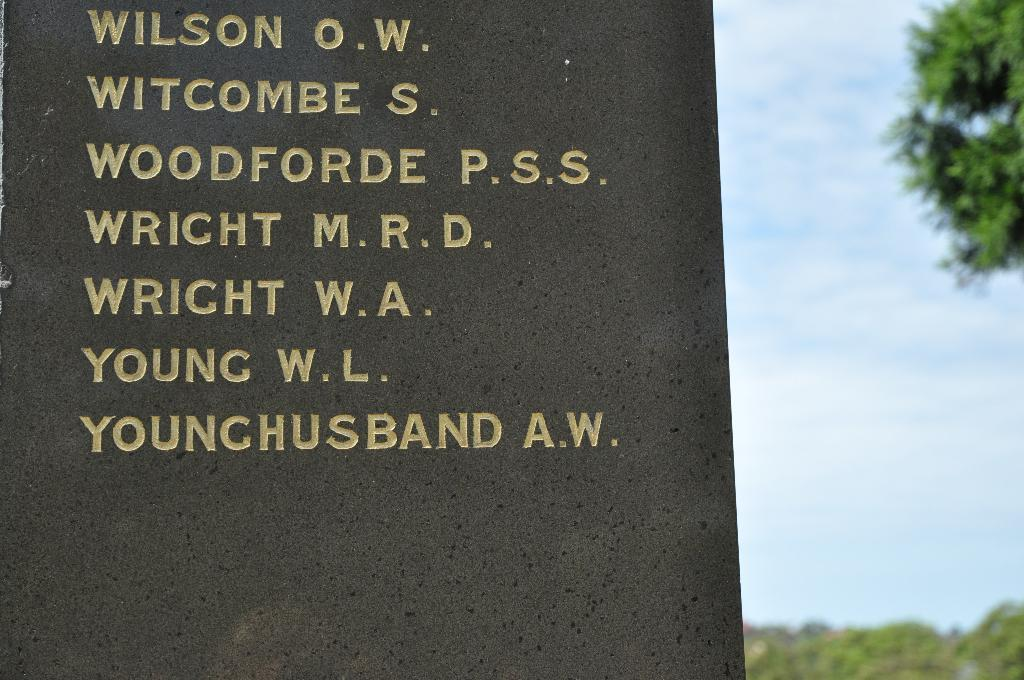What is written or depicted on the wall in the image? There is a wall with text in the image. What type of vegetation can be seen on the right side of the image? There are trees and plants on the right side of the image. What part of the natural environment is visible in the image? The sky is visible in the image. What can be observed in the sky in the image? Clouds are present in the sky. What type of sponge is being used to clean the wall in the image? There is no sponge present in the image, and the wall does not appear to be in need of cleaning. 